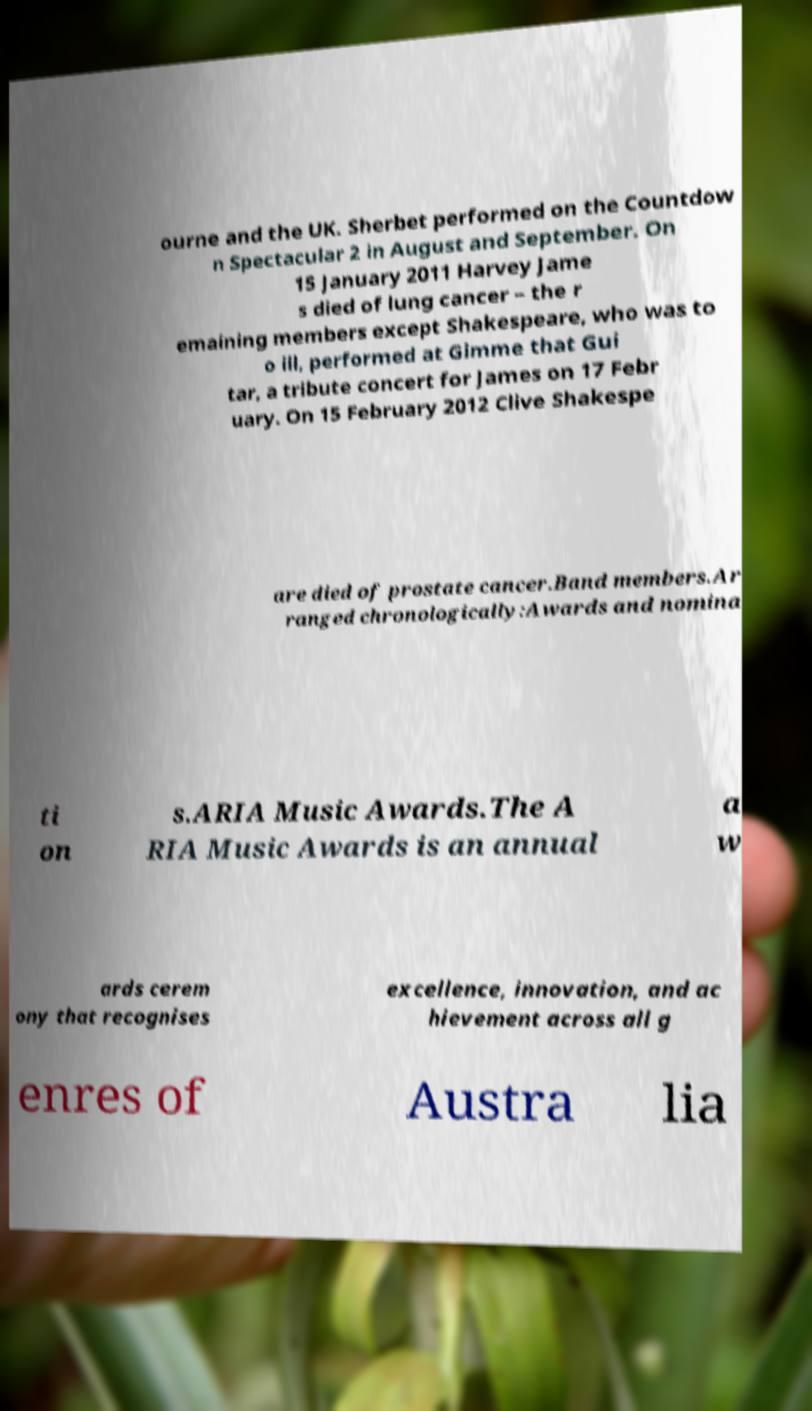Please identify and transcribe the text found in this image. ourne and the UK. Sherbet performed on the Countdow n Spectacular 2 in August and September. On 15 January 2011 Harvey Jame s died of lung cancer – the r emaining members except Shakespeare, who was to o ill, performed at Gimme that Gui tar, a tribute concert for James on 17 Febr uary. On 15 February 2012 Clive Shakespe are died of prostate cancer.Band members.Ar ranged chronologically:Awards and nomina ti on s.ARIA Music Awards.The A RIA Music Awards is an annual a w ards cerem ony that recognises excellence, innovation, and ac hievement across all g enres of Austra lia 